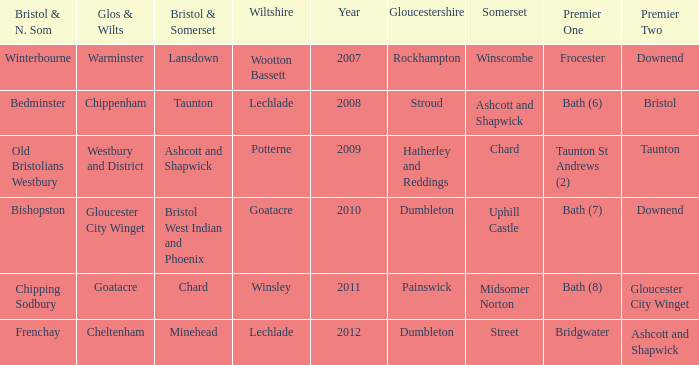What is the glos & wilts where the bristol & somerset is lansdown? Warminster. 